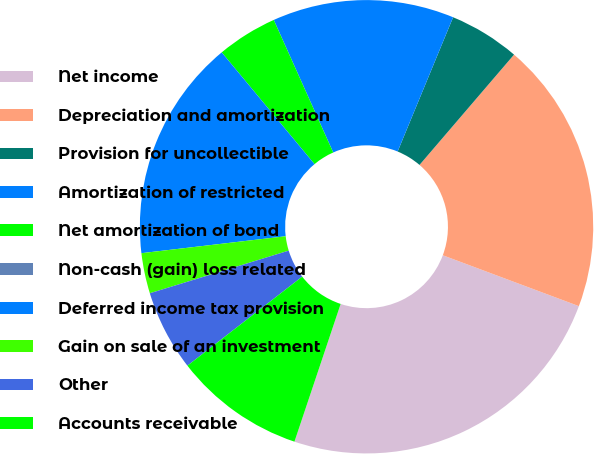Convert chart to OTSL. <chart><loc_0><loc_0><loc_500><loc_500><pie_chart><fcel>Net income<fcel>Depreciation and amortization<fcel>Provision for uncollectible<fcel>Amortization of restricted<fcel>Net amortization of bond<fcel>Non-cash (gain) loss related<fcel>Deferred income tax provision<fcel>Gain on sale of an investment<fcel>Other<fcel>Accounts receivable<nl><fcel>24.46%<fcel>19.42%<fcel>5.04%<fcel>12.95%<fcel>4.32%<fcel>0.0%<fcel>15.83%<fcel>2.88%<fcel>5.76%<fcel>9.35%<nl></chart> 